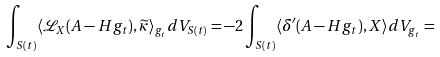Convert formula to latex. <formula><loc_0><loc_0><loc_500><loc_500>\int _ { S ( t ) } \langle { \mathcal { L } } _ { X } ( A - H g _ { t } ) , \widetilde { \kappa } \rangle _ { g _ { t } } d V _ { S ( t ) } = - 2 \int _ { S ( t ) } \langle \delta ^ { \prime } ( A - H g _ { t } ) , X \rangle d V _ { g _ { t } } =</formula> 